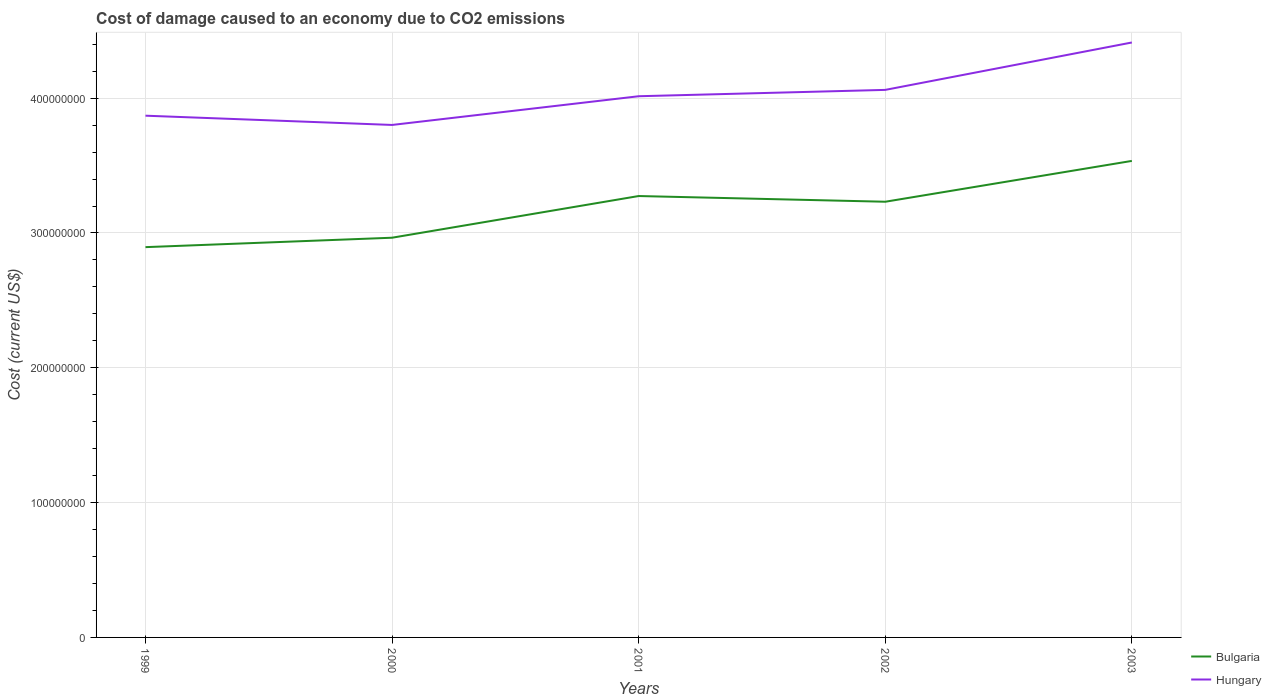How many different coloured lines are there?
Make the answer very short. 2. Across all years, what is the maximum cost of damage caused due to CO2 emissisons in Hungary?
Your response must be concise. 3.80e+08. What is the total cost of damage caused due to CO2 emissisons in Bulgaria in the graph?
Keep it short and to the point. -3.37e+07. What is the difference between the highest and the second highest cost of damage caused due to CO2 emissisons in Bulgaria?
Ensure brevity in your answer.  6.40e+07. What is the difference between the highest and the lowest cost of damage caused due to CO2 emissisons in Bulgaria?
Your answer should be very brief. 3. What is the difference between two consecutive major ticks on the Y-axis?
Your answer should be compact. 1.00e+08. Are the values on the major ticks of Y-axis written in scientific E-notation?
Ensure brevity in your answer.  No. Does the graph contain any zero values?
Give a very brief answer. No. How many legend labels are there?
Your answer should be very brief. 2. How are the legend labels stacked?
Your answer should be compact. Vertical. What is the title of the graph?
Make the answer very short. Cost of damage caused to an economy due to CO2 emissions. What is the label or title of the Y-axis?
Provide a short and direct response. Cost (current US$). What is the Cost (current US$) in Bulgaria in 1999?
Offer a very short reply. 2.89e+08. What is the Cost (current US$) of Hungary in 1999?
Your answer should be very brief. 3.87e+08. What is the Cost (current US$) in Bulgaria in 2000?
Offer a terse response. 2.96e+08. What is the Cost (current US$) in Hungary in 2000?
Your answer should be compact. 3.80e+08. What is the Cost (current US$) in Bulgaria in 2001?
Your answer should be compact. 3.27e+08. What is the Cost (current US$) in Hungary in 2001?
Keep it short and to the point. 4.01e+08. What is the Cost (current US$) in Bulgaria in 2002?
Your response must be concise. 3.23e+08. What is the Cost (current US$) of Hungary in 2002?
Offer a terse response. 4.06e+08. What is the Cost (current US$) in Bulgaria in 2003?
Give a very brief answer. 3.53e+08. What is the Cost (current US$) in Hungary in 2003?
Make the answer very short. 4.41e+08. Across all years, what is the maximum Cost (current US$) in Bulgaria?
Offer a very short reply. 3.53e+08. Across all years, what is the maximum Cost (current US$) of Hungary?
Keep it short and to the point. 4.41e+08. Across all years, what is the minimum Cost (current US$) of Bulgaria?
Provide a short and direct response. 2.89e+08. Across all years, what is the minimum Cost (current US$) of Hungary?
Make the answer very short. 3.80e+08. What is the total Cost (current US$) in Bulgaria in the graph?
Offer a very short reply. 1.59e+09. What is the total Cost (current US$) in Hungary in the graph?
Provide a short and direct response. 2.02e+09. What is the difference between the Cost (current US$) in Bulgaria in 1999 and that in 2000?
Your answer should be very brief. -6.99e+06. What is the difference between the Cost (current US$) in Hungary in 1999 and that in 2000?
Keep it short and to the point. 6.87e+06. What is the difference between the Cost (current US$) of Bulgaria in 1999 and that in 2001?
Offer a very short reply. -3.79e+07. What is the difference between the Cost (current US$) of Hungary in 1999 and that in 2001?
Your answer should be compact. -1.44e+07. What is the difference between the Cost (current US$) in Bulgaria in 1999 and that in 2002?
Provide a short and direct response. -3.37e+07. What is the difference between the Cost (current US$) of Hungary in 1999 and that in 2002?
Make the answer very short. -1.91e+07. What is the difference between the Cost (current US$) in Bulgaria in 1999 and that in 2003?
Make the answer very short. -6.40e+07. What is the difference between the Cost (current US$) of Hungary in 1999 and that in 2003?
Ensure brevity in your answer.  -5.43e+07. What is the difference between the Cost (current US$) of Bulgaria in 2000 and that in 2001?
Ensure brevity in your answer.  -3.09e+07. What is the difference between the Cost (current US$) of Hungary in 2000 and that in 2001?
Offer a terse response. -2.13e+07. What is the difference between the Cost (current US$) in Bulgaria in 2000 and that in 2002?
Provide a short and direct response. -2.67e+07. What is the difference between the Cost (current US$) of Hungary in 2000 and that in 2002?
Ensure brevity in your answer.  -2.60e+07. What is the difference between the Cost (current US$) of Bulgaria in 2000 and that in 2003?
Your answer should be compact. -5.70e+07. What is the difference between the Cost (current US$) in Hungary in 2000 and that in 2003?
Keep it short and to the point. -6.12e+07. What is the difference between the Cost (current US$) in Bulgaria in 2001 and that in 2002?
Make the answer very short. 4.23e+06. What is the difference between the Cost (current US$) of Hungary in 2001 and that in 2002?
Your answer should be compact. -4.72e+06. What is the difference between the Cost (current US$) in Bulgaria in 2001 and that in 2003?
Give a very brief answer. -2.61e+07. What is the difference between the Cost (current US$) of Hungary in 2001 and that in 2003?
Provide a succinct answer. -3.99e+07. What is the difference between the Cost (current US$) in Bulgaria in 2002 and that in 2003?
Offer a terse response. -3.03e+07. What is the difference between the Cost (current US$) in Hungary in 2002 and that in 2003?
Your answer should be compact. -3.52e+07. What is the difference between the Cost (current US$) of Bulgaria in 1999 and the Cost (current US$) of Hungary in 2000?
Ensure brevity in your answer.  -9.06e+07. What is the difference between the Cost (current US$) in Bulgaria in 1999 and the Cost (current US$) in Hungary in 2001?
Your answer should be compact. -1.12e+08. What is the difference between the Cost (current US$) of Bulgaria in 1999 and the Cost (current US$) of Hungary in 2002?
Keep it short and to the point. -1.17e+08. What is the difference between the Cost (current US$) of Bulgaria in 1999 and the Cost (current US$) of Hungary in 2003?
Offer a very short reply. -1.52e+08. What is the difference between the Cost (current US$) of Bulgaria in 2000 and the Cost (current US$) of Hungary in 2001?
Offer a terse response. -1.05e+08. What is the difference between the Cost (current US$) in Bulgaria in 2000 and the Cost (current US$) in Hungary in 2002?
Keep it short and to the point. -1.10e+08. What is the difference between the Cost (current US$) of Bulgaria in 2000 and the Cost (current US$) of Hungary in 2003?
Your response must be concise. -1.45e+08. What is the difference between the Cost (current US$) of Bulgaria in 2001 and the Cost (current US$) of Hungary in 2002?
Your answer should be compact. -7.87e+07. What is the difference between the Cost (current US$) of Bulgaria in 2001 and the Cost (current US$) of Hungary in 2003?
Keep it short and to the point. -1.14e+08. What is the difference between the Cost (current US$) of Bulgaria in 2002 and the Cost (current US$) of Hungary in 2003?
Your answer should be very brief. -1.18e+08. What is the average Cost (current US$) in Bulgaria per year?
Your answer should be compact. 3.18e+08. What is the average Cost (current US$) of Hungary per year?
Keep it short and to the point. 4.03e+08. In the year 1999, what is the difference between the Cost (current US$) in Bulgaria and Cost (current US$) in Hungary?
Make the answer very short. -9.75e+07. In the year 2000, what is the difference between the Cost (current US$) of Bulgaria and Cost (current US$) of Hungary?
Give a very brief answer. -8.36e+07. In the year 2001, what is the difference between the Cost (current US$) of Bulgaria and Cost (current US$) of Hungary?
Ensure brevity in your answer.  -7.40e+07. In the year 2002, what is the difference between the Cost (current US$) in Bulgaria and Cost (current US$) in Hungary?
Keep it short and to the point. -8.30e+07. In the year 2003, what is the difference between the Cost (current US$) in Bulgaria and Cost (current US$) in Hungary?
Offer a terse response. -8.78e+07. What is the ratio of the Cost (current US$) in Bulgaria in 1999 to that in 2000?
Ensure brevity in your answer.  0.98. What is the ratio of the Cost (current US$) in Hungary in 1999 to that in 2000?
Your response must be concise. 1.02. What is the ratio of the Cost (current US$) in Bulgaria in 1999 to that in 2001?
Offer a terse response. 0.88. What is the ratio of the Cost (current US$) in Hungary in 1999 to that in 2001?
Provide a succinct answer. 0.96. What is the ratio of the Cost (current US$) in Bulgaria in 1999 to that in 2002?
Your answer should be very brief. 0.9. What is the ratio of the Cost (current US$) in Hungary in 1999 to that in 2002?
Your answer should be compact. 0.95. What is the ratio of the Cost (current US$) of Bulgaria in 1999 to that in 2003?
Offer a very short reply. 0.82. What is the ratio of the Cost (current US$) in Hungary in 1999 to that in 2003?
Offer a very short reply. 0.88. What is the ratio of the Cost (current US$) in Bulgaria in 2000 to that in 2001?
Offer a very short reply. 0.91. What is the ratio of the Cost (current US$) of Hungary in 2000 to that in 2001?
Provide a succinct answer. 0.95. What is the ratio of the Cost (current US$) in Bulgaria in 2000 to that in 2002?
Your answer should be very brief. 0.92. What is the ratio of the Cost (current US$) in Hungary in 2000 to that in 2002?
Keep it short and to the point. 0.94. What is the ratio of the Cost (current US$) in Bulgaria in 2000 to that in 2003?
Offer a very short reply. 0.84. What is the ratio of the Cost (current US$) of Hungary in 2000 to that in 2003?
Provide a short and direct response. 0.86. What is the ratio of the Cost (current US$) of Bulgaria in 2001 to that in 2002?
Keep it short and to the point. 1.01. What is the ratio of the Cost (current US$) of Hungary in 2001 to that in 2002?
Give a very brief answer. 0.99. What is the ratio of the Cost (current US$) in Bulgaria in 2001 to that in 2003?
Offer a terse response. 0.93. What is the ratio of the Cost (current US$) of Hungary in 2001 to that in 2003?
Provide a succinct answer. 0.91. What is the ratio of the Cost (current US$) in Bulgaria in 2002 to that in 2003?
Your answer should be very brief. 0.91. What is the ratio of the Cost (current US$) of Hungary in 2002 to that in 2003?
Offer a terse response. 0.92. What is the difference between the highest and the second highest Cost (current US$) in Bulgaria?
Provide a succinct answer. 2.61e+07. What is the difference between the highest and the second highest Cost (current US$) of Hungary?
Offer a terse response. 3.52e+07. What is the difference between the highest and the lowest Cost (current US$) of Bulgaria?
Keep it short and to the point. 6.40e+07. What is the difference between the highest and the lowest Cost (current US$) of Hungary?
Your response must be concise. 6.12e+07. 